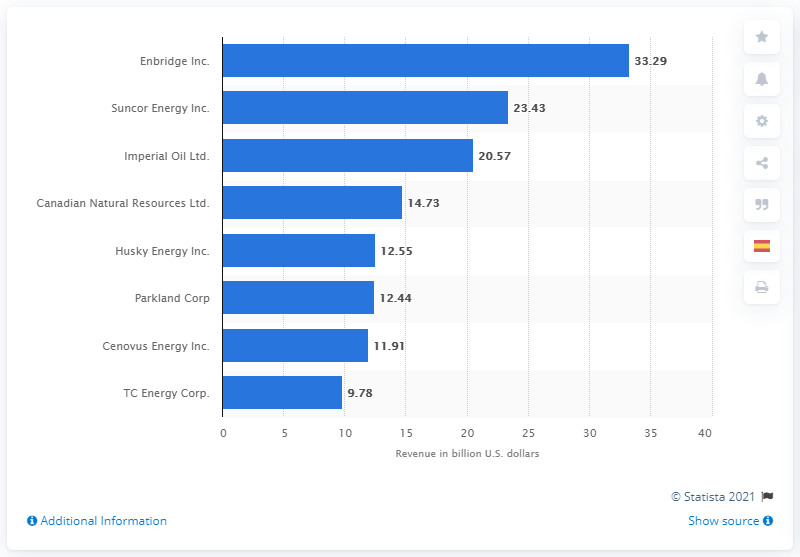Point out several critical features in this image. Enbridge's revenue in the previous fiscal year was 33.29. 